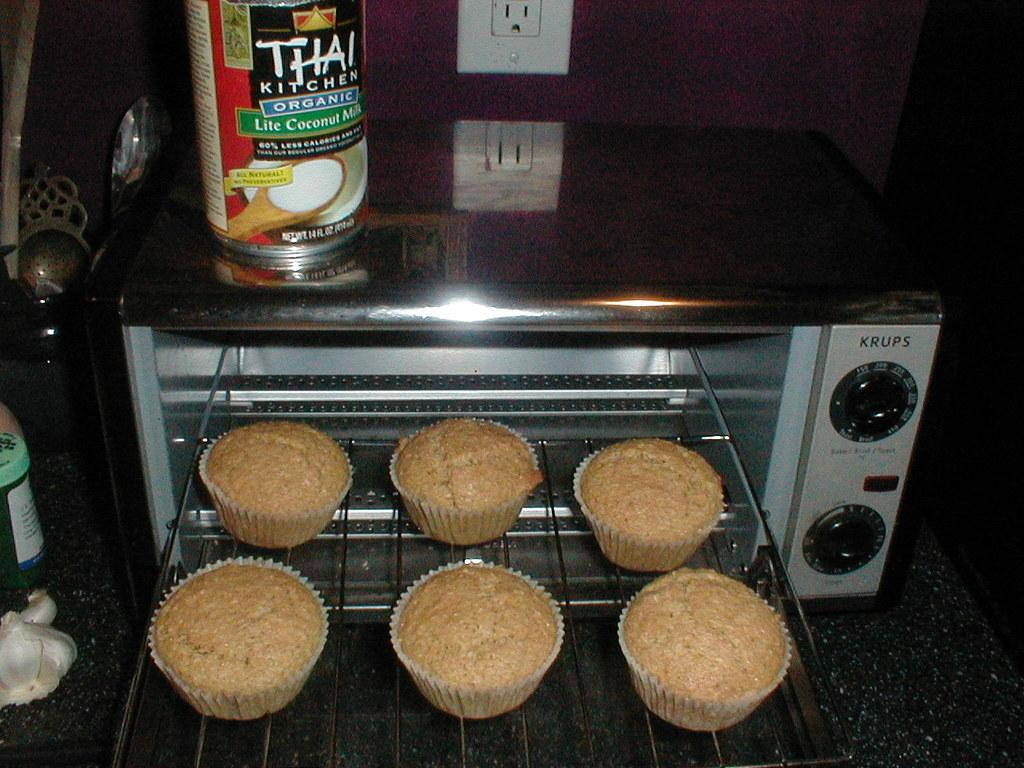<image>
Render a clear and concise summary of the photo. krups toaster oven with muffins coming out of it and a container of lite coconut milk above 